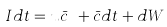<formula> <loc_0><loc_0><loc_500><loc_500>I d t = u \bar { c } ^ { \dagger } + \bar { c } d t + d W</formula> 